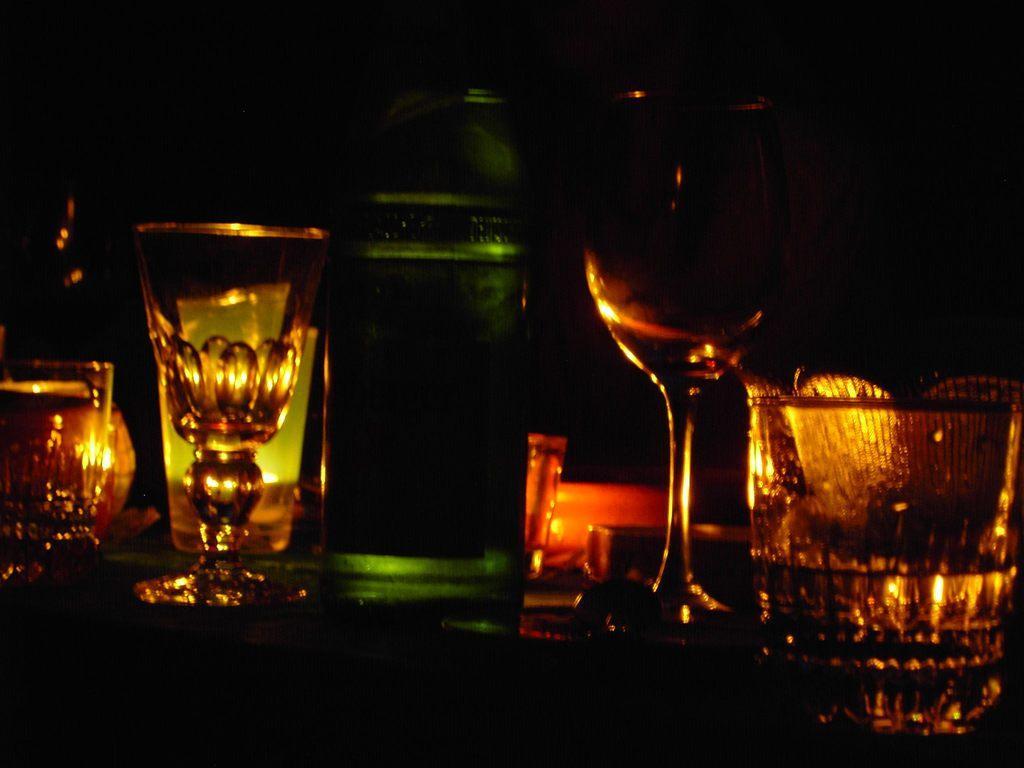How would you summarize this image in a sentence or two? In this picture we can see some glasses and bottles which are on the surface. 